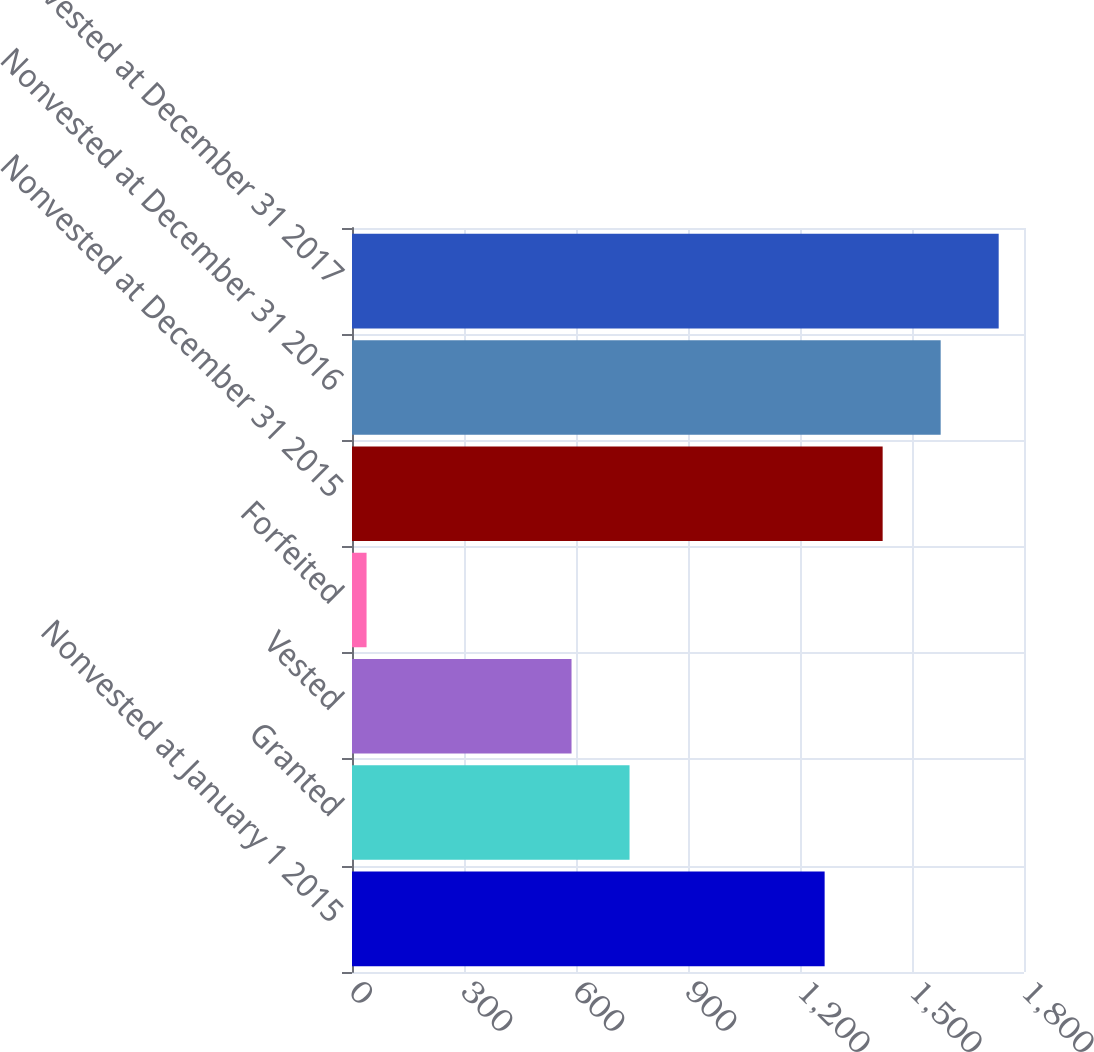Convert chart to OTSL. <chart><loc_0><loc_0><loc_500><loc_500><bar_chart><fcel>Nonvested at January 1 2015<fcel>Granted<fcel>Vested<fcel>Forfeited<fcel>Nonvested at December 31 2015<fcel>Nonvested at December 31 2016<fcel>Nonvested at December 31 2017<nl><fcel>1266<fcel>743.4<fcel>588<fcel>39<fcel>1421.4<fcel>1576.8<fcel>1732.2<nl></chart> 